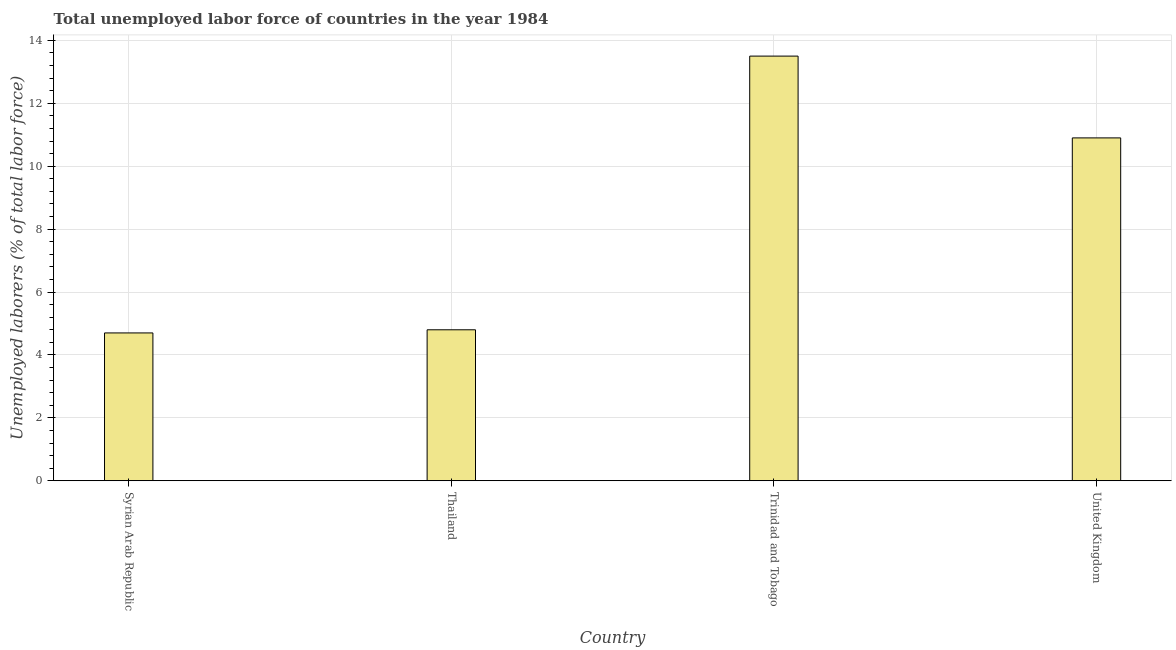Does the graph contain any zero values?
Offer a very short reply. No. Does the graph contain grids?
Make the answer very short. Yes. What is the title of the graph?
Ensure brevity in your answer.  Total unemployed labor force of countries in the year 1984. What is the label or title of the X-axis?
Offer a very short reply. Country. What is the label or title of the Y-axis?
Provide a short and direct response. Unemployed laborers (% of total labor force). What is the total unemployed labour force in United Kingdom?
Make the answer very short. 10.9. Across all countries, what is the minimum total unemployed labour force?
Ensure brevity in your answer.  4.7. In which country was the total unemployed labour force maximum?
Your answer should be very brief. Trinidad and Tobago. In which country was the total unemployed labour force minimum?
Offer a terse response. Syrian Arab Republic. What is the sum of the total unemployed labour force?
Ensure brevity in your answer.  33.9. What is the difference between the total unemployed labour force in Thailand and United Kingdom?
Provide a succinct answer. -6.1. What is the average total unemployed labour force per country?
Keep it short and to the point. 8.47. What is the median total unemployed labour force?
Offer a terse response. 7.85. In how many countries, is the total unemployed labour force greater than 1.6 %?
Give a very brief answer. 4. What is the ratio of the total unemployed labour force in Syrian Arab Republic to that in United Kingdom?
Your answer should be compact. 0.43. What is the difference between the highest and the lowest total unemployed labour force?
Make the answer very short. 8.8. In how many countries, is the total unemployed labour force greater than the average total unemployed labour force taken over all countries?
Provide a short and direct response. 2. How many countries are there in the graph?
Your answer should be compact. 4. What is the difference between two consecutive major ticks on the Y-axis?
Offer a terse response. 2. What is the Unemployed laborers (% of total labor force) of Syrian Arab Republic?
Offer a terse response. 4.7. What is the Unemployed laborers (% of total labor force) of Thailand?
Your answer should be compact. 4.8. What is the Unemployed laborers (% of total labor force) of United Kingdom?
Your response must be concise. 10.9. What is the difference between the Unemployed laborers (% of total labor force) in Syrian Arab Republic and Thailand?
Provide a short and direct response. -0.1. What is the difference between the Unemployed laborers (% of total labor force) in Thailand and United Kingdom?
Provide a succinct answer. -6.1. What is the difference between the Unemployed laborers (% of total labor force) in Trinidad and Tobago and United Kingdom?
Provide a succinct answer. 2.6. What is the ratio of the Unemployed laborers (% of total labor force) in Syrian Arab Republic to that in Thailand?
Keep it short and to the point. 0.98. What is the ratio of the Unemployed laborers (% of total labor force) in Syrian Arab Republic to that in Trinidad and Tobago?
Provide a short and direct response. 0.35. What is the ratio of the Unemployed laborers (% of total labor force) in Syrian Arab Republic to that in United Kingdom?
Your response must be concise. 0.43. What is the ratio of the Unemployed laborers (% of total labor force) in Thailand to that in Trinidad and Tobago?
Keep it short and to the point. 0.36. What is the ratio of the Unemployed laborers (% of total labor force) in Thailand to that in United Kingdom?
Offer a very short reply. 0.44. What is the ratio of the Unemployed laborers (% of total labor force) in Trinidad and Tobago to that in United Kingdom?
Provide a succinct answer. 1.24. 